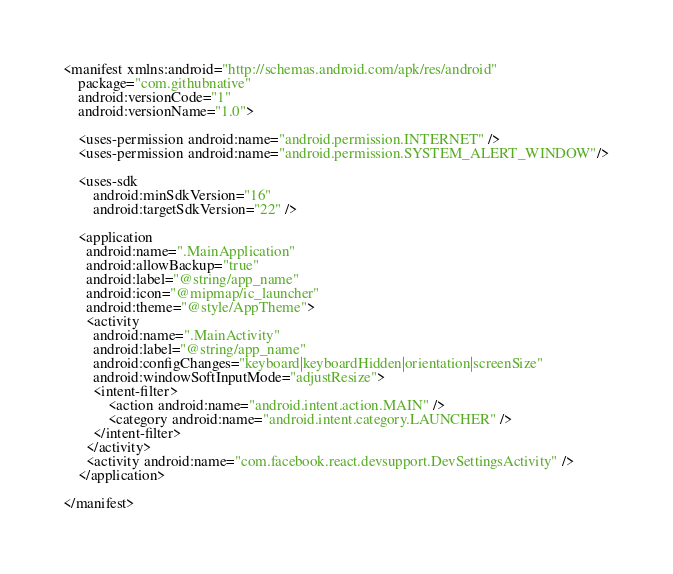<code> <loc_0><loc_0><loc_500><loc_500><_XML_><manifest xmlns:android="http://schemas.android.com/apk/res/android"
    package="com.githubnative"
    android:versionCode="1"
    android:versionName="1.0">

    <uses-permission android:name="android.permission.INTERNET" />
    <uses-permission android:name="android.permission.SYSTEM_ALERT_WINDOW"/>

    <uses-sdk
        android:minSdkVersion="16"
        android:targetSdkVersion="22" />

    <application
      android:name=".MainApplication"
      android:allowBackup="true"
      android:label="@string/app_name"
      android:icon="@mipmap/ic_launcher"
      android:theme="@style/AppTheme">
      <activity
        android:name=".MainActivity"
        android:label="@string/app_name"
        android:configChanges="keyboard|keyboardHidden|orientation|screenSize"
        android:windowSoftInputMode="adjustResize">
        <intent-filter>
            <action android:name="android.intent.action.MAIN" />
            <category android:name="android.intent.category.LAUNCHER" />
        </intent-filter>
      </activity>
      <activity android:name="com.facebook.react.devsupport.DevSettingsActivity" />
    </application>

</manifest>
</code> 